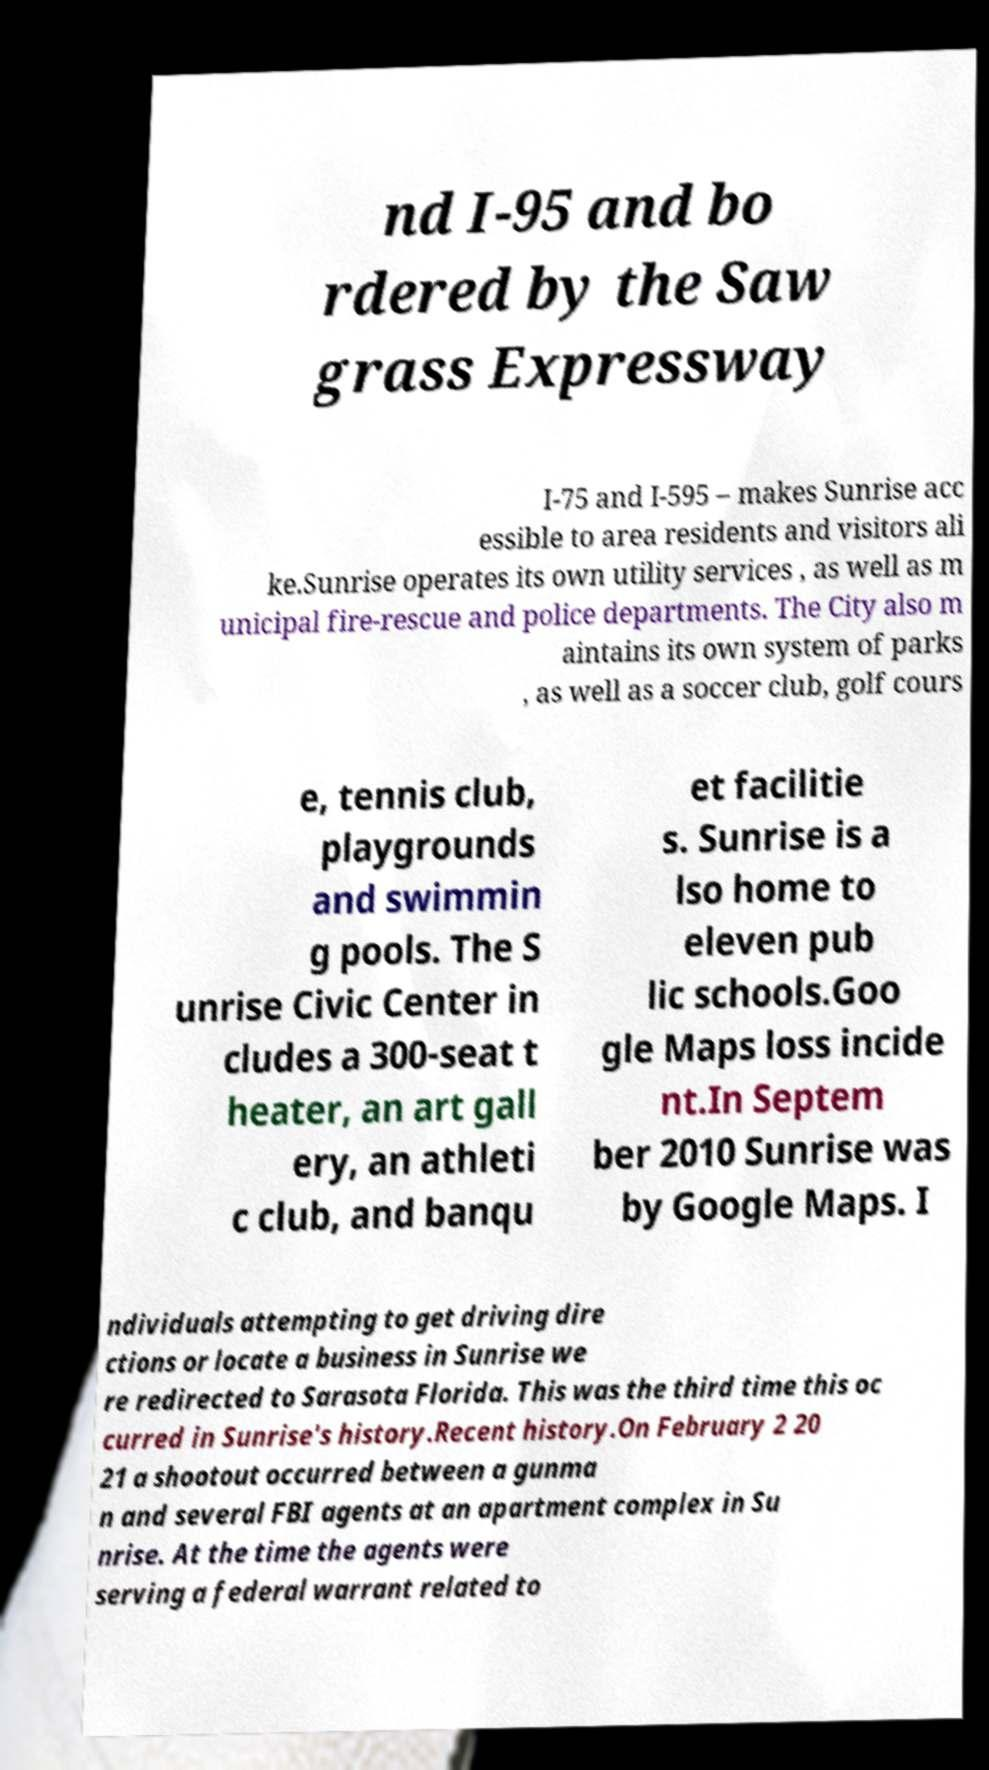There's text embedded in this image that I need extracted. Can you transcribe it verbatim? nd I-95 and bo rdered by the Saw grass Expressway I-75 and I-595 – makes Sunrise acc essible to area residents and visitors ali ke.Sunrise operates its own utility services , as well as m unicipal fire-rescue and police departments. The City also m aintains its own system of parks , as well as a soccer club, golf cours e, tennis club, playgrounds and swimmin g pools. The S unrise Civic Center in cludes a 300-seat t heater, an art gall ery, an athleti c club, and banqu et facilitie s. Sunrise is a lso home to eleven pub lic schools.Goo gle Maps loss incide nt.In Septem ber 2010 Sunrise was by Google Maps. I ndividuals attempting to get driving dire ctions or locate a business in Sunrise we re redirected to Sarasota Florida. This was the third time this oc curred in Sunrise's history.Recent history.On February 2 20 21 a shootout occurred between a gunma n and several FBI agents at an apartment complex in Su nrise. At the time the agents were serving a federal warrant related to 